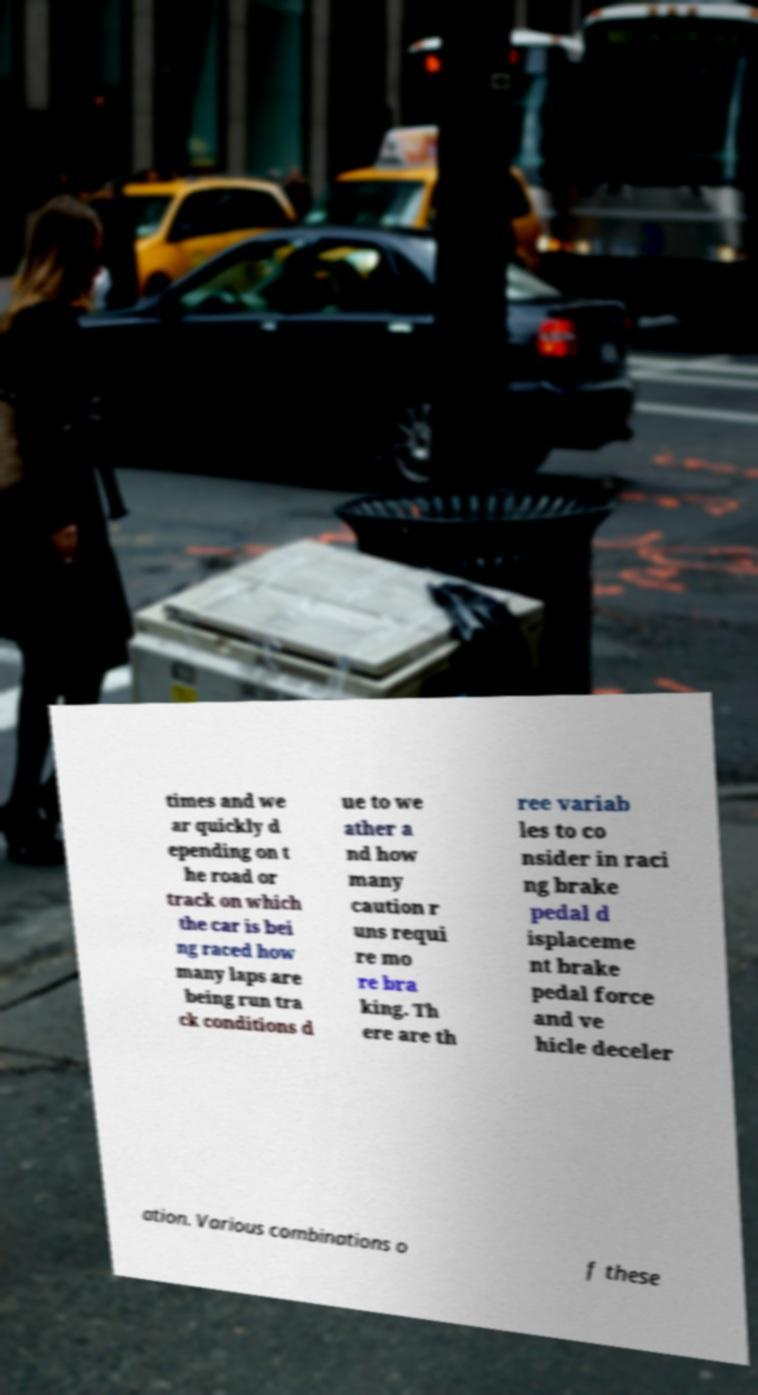Could you assist in decoding the text presented in this image and type it out clearly? times and we ar quickly d epending on t he road or track on which the car is bei ng raced how many laps are being run tra ck conditions d ue to we ather a nd how many caution r uns requi re mo re bra king. Th ere are th ree variab les to co nsider in raci ng brake pedal d isplaceme nt brake pedal force and ve hicle deceler ation. Various combinations o f these 